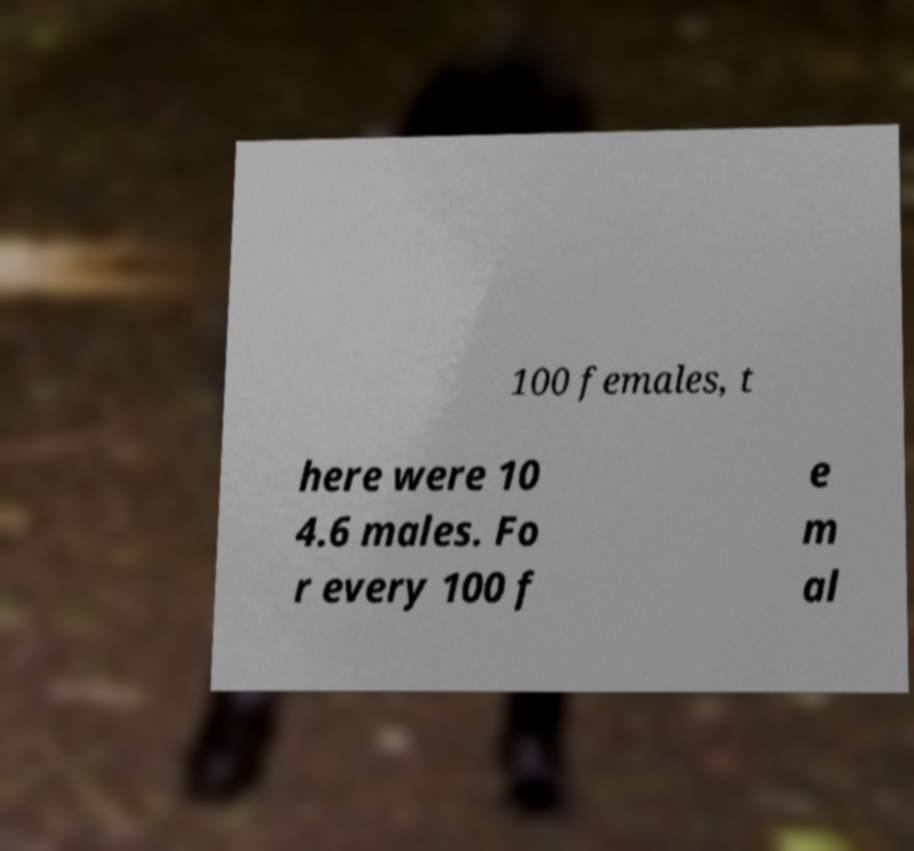Please read and relay the text visible in this image. What does it say? 100 females, t here were 10 4.6 males. Fo r every 100 f e m al 